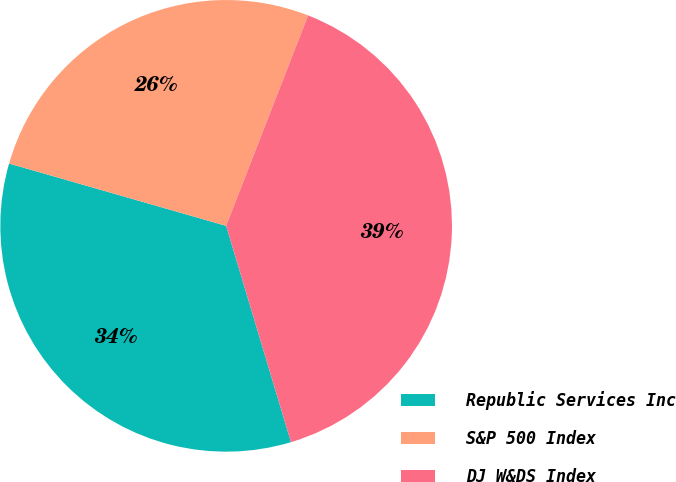Convert chart to OTSL. <chart><loc_0><loc_0><loc_500><loc_500><pie_chart><fcel>Republic Services Inc<fcel>S&P 500 Index<fcel>DJ W&DS Index<nl><fcel>34.08%<fcel>26.46%<fcel>39.45%<nl></chart> 